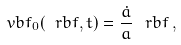Convert formula to latex. <formula><loc_0><loc_0><loc_500><loc_500>\ v b f _ { 0 } ( \ r b f , t ) = \frac { \dot { a } } { a } \, \ r b f \, ,</formula> 